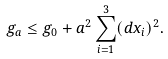<formula> <loc_0><loc_0><loc_500><loc_500>g _ { a } \leq g _ { 0 } + a ^ { 2 } \sum _ { i = 1 } ^ { 3 } ( d x _ { i } ) ^ { 2 } .</formula> 